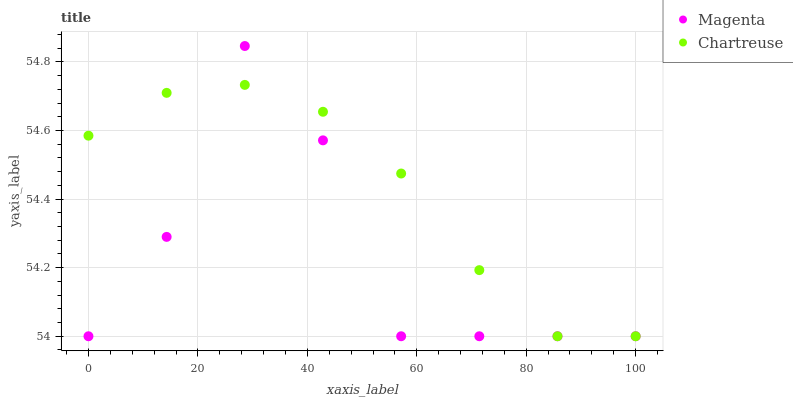Does Magenta have the minimum area under the curve?
Answer yes or no. Yes. Does Chartreuse have the maximum area under the curve?
Answer yes or no. Yes. Does Chartreuse have the minimum area under the curve?
Answer yes or no. No. Is Chartreuse the smoothest?
Answer yes or no. Yes. Is Magenta the roughest?
Answer yes or no. Yes. Is Chartreuse the roughest?
Answer yes or no. No. Does Magenta have the lowest value?
Answer yes or no. Yes. Does Magenta have the highest value?
Answer yes or no. Yes. Does Chartreuse have the highest value?
Answer yes or no. No. Does Magenta intersect Chartreuse?
Answer yes or no. Yes. Is Magenta less than Chartreuse?
Answer yes or no. No. Is Magenta greater than Chartreuse?
Answer yes or no. No. 